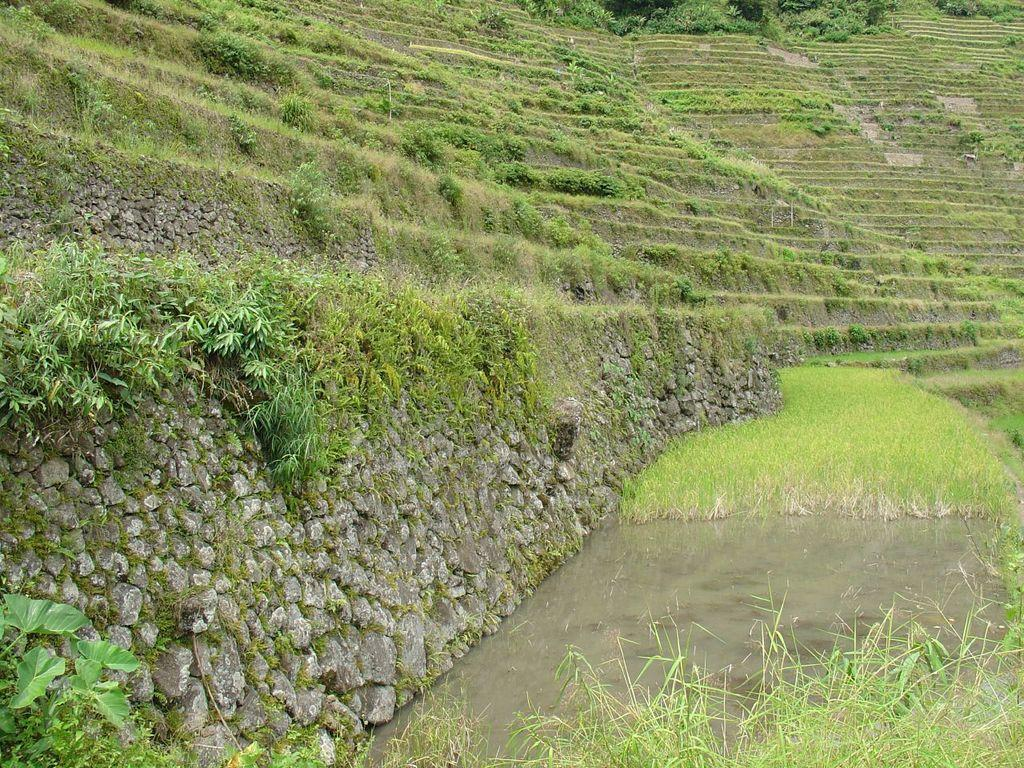What type of landscape feature is present in the image? There is a hill in the image. What can be found on the hill? The hill has stones and grass. Where is the pond located in the image? The pond is at the bottom right of the image. What is growing near the pond? Plants are present near the pond. What type of destruction is happening to the hill in the image? There is no destruction happening to the hill in the image. The hill appears to be in a natural state with stones and grass. 